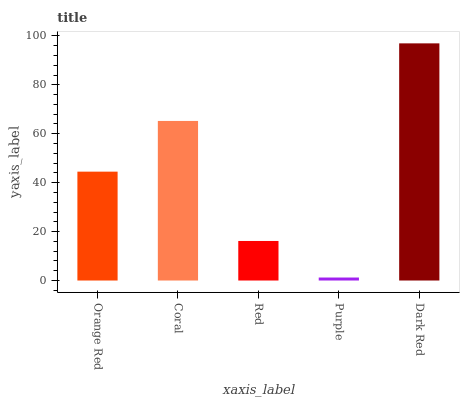Is Purple the minimum?
Answer yes or no. Yes. Is Dark Red the maximum?
Answer yes or no. Yes. Is Coral the minimum?
Answer yes or no. No. Is Coral the maximum?
Answer yes or no. No. Is Coral greater than Orange Red?
Answer yes or no. Yes. Is Orange Red less than Coral?
Answer yes or no. Yes. Is Orange Red greater than Coral?
Answer yes or no. No. Is Coral less than Orange Red?
Answer yes or no. No. Is Orange Red the high median?
Answer yes or no. Yes. Is Orange Red the low median?
Answer yes or no. Yes. Is Purple the high median?
Answer yes or no. No. Is Coral the low median?
Answer yes or no. No. 